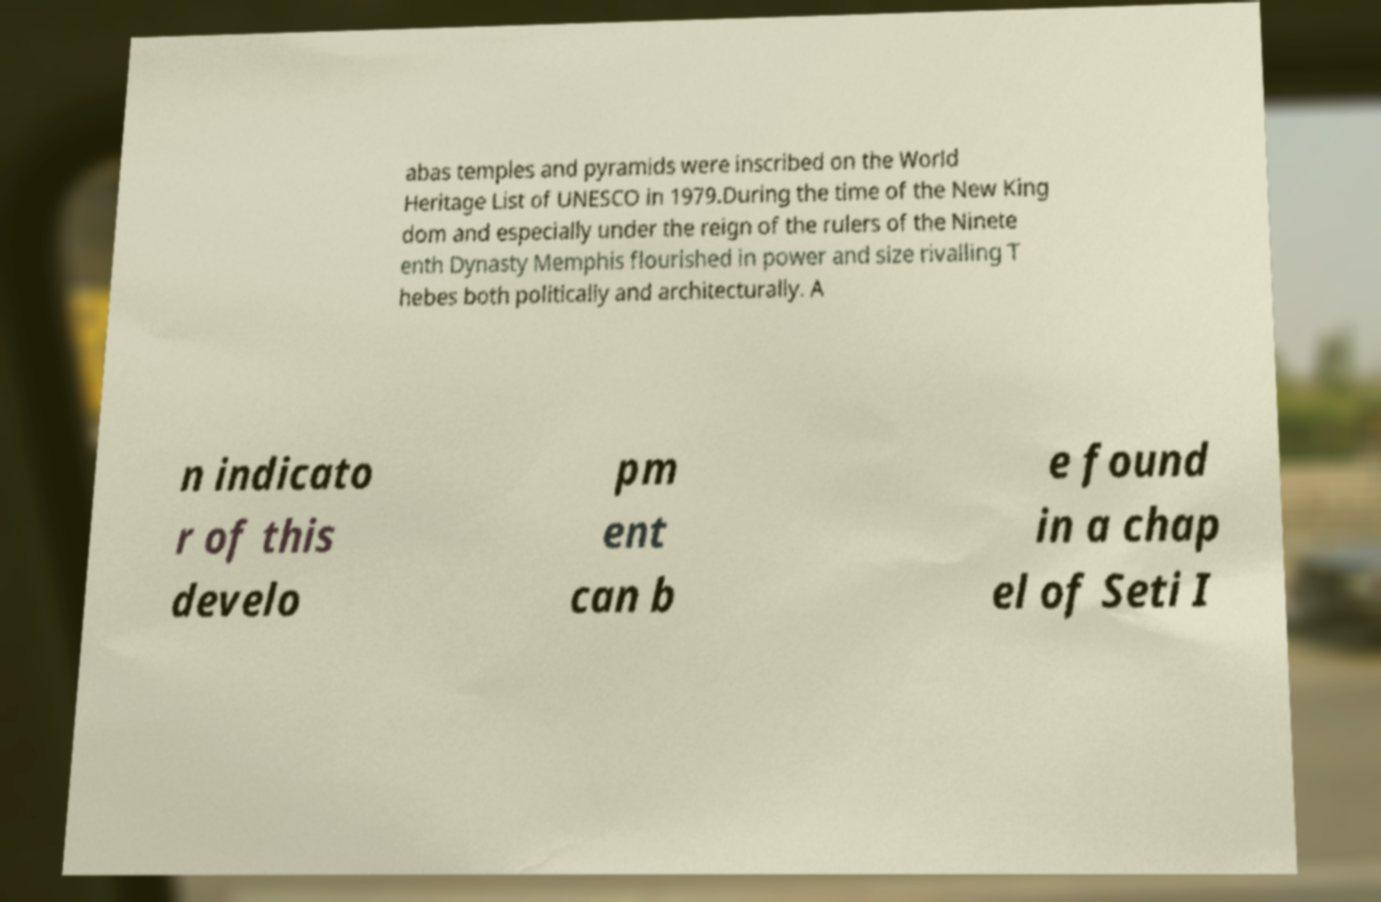What messages or text are displayed in this image? I need them in a readable, typed format. abas temples and pyramids were inscribed on the World Heritage List of UNESCO in 1979.During the time of the New King dom and especially under the reign of the rulers of the Ninete enth Dynasty Memphis flourished in power and size rivalling T hebes both politically and architecturally. A n indicato r of this develo pm ent can b e found in a chap el of Seti I 